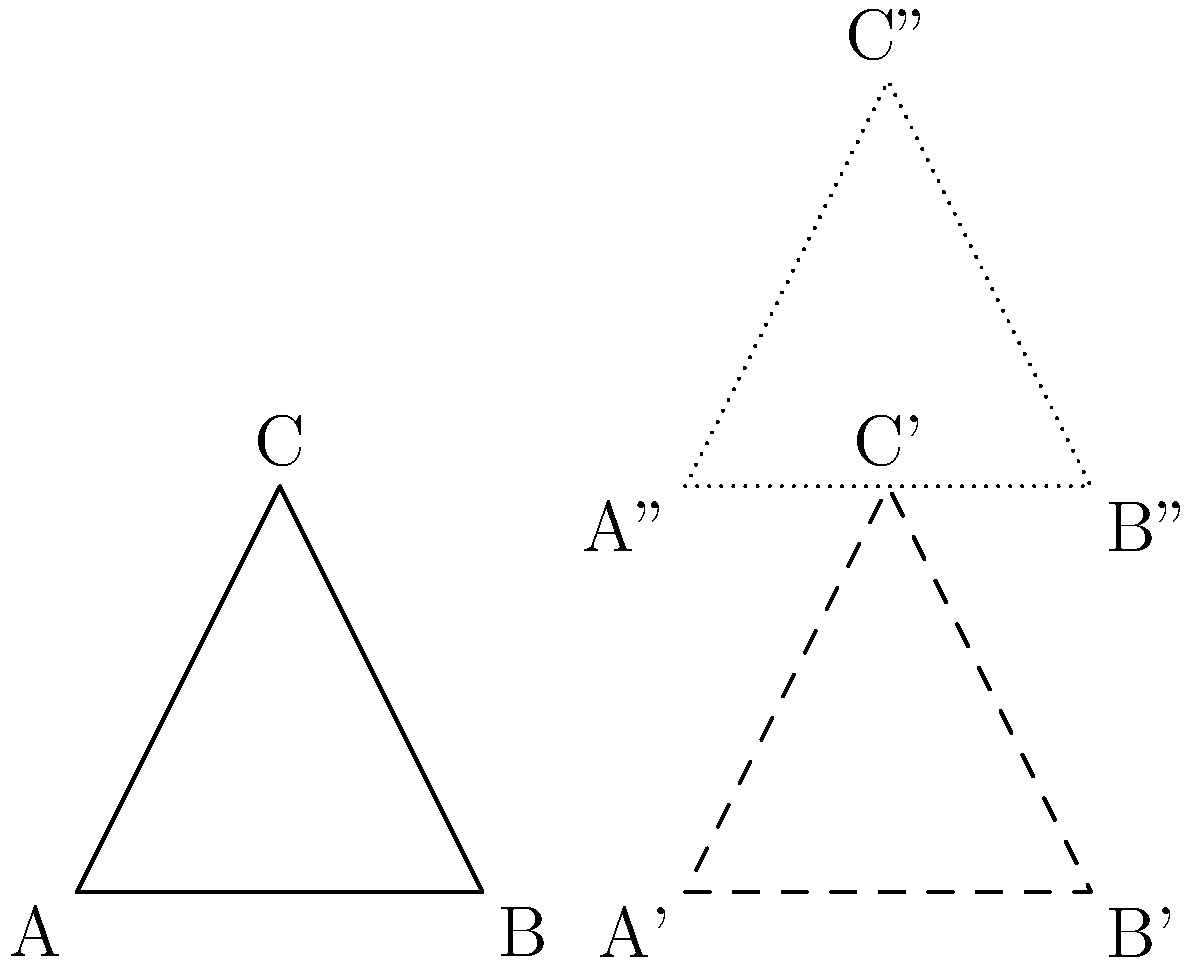Given triangle ABC, determine the composition of transformations that maps triangle ABC to triangle A''B''C''. Express your answer as a single transformation matrix. To solve this problem, we need to follow these steps:

1) First, observe that triangle ABC is transformed to triangle A'B'C' by a translation of 3 units to the right. The translation matrix for this is:

   $$T_1 = \begin{bmatrix} 1 & 0 & 3 \\ 0 & 1 & 0 \\ 0 & 0 & 1 \end{bmatrix}$$

2) Then, triangle A'B'C' is transformed to triangle A''B''C'' by a translation of 2 units upward. The translation matrix for this is:

   $$T_2 = \begin{bmatrix} 1 & 0 & 0 \\ 0 & 1 & 2 \\ 0 & 0 & 1 \end{bmatrix}$$

3) To find the composition of these transformations, we multiply the matrices in the order of application (right to left):

   $$T = T_2 \cdot T_1 = \begin{bmatrix} 1 & 0 & 0 \\ 0 & 1 & 2 \\ 0 & 0 & 1 \end{bmatrix} \cdot \begin{bmatrix} 1 & 0 & 3 \\ 0 & 1 & 0 \\ 0 & 0 & 1 \end{bmatrix}$$

4) Performing the matrix multiplication:

   $$T = \begin{bmatrix} 1 & 0 & 3 \\ 0 & 1 & 2 \\ 0 & 0 & 1 \end{bmatrix}$$

This final matrix represents a single translation that moves points 3 units right and 2 units up, which is equivalent to the two separate translations applied in sequence.
Answer: $$\begin{bmatrix} 1 & 0 & 3 \\ 0 & 1 & 2 \\ 0 & 0 & 1 \end{bmatrix}$$ 